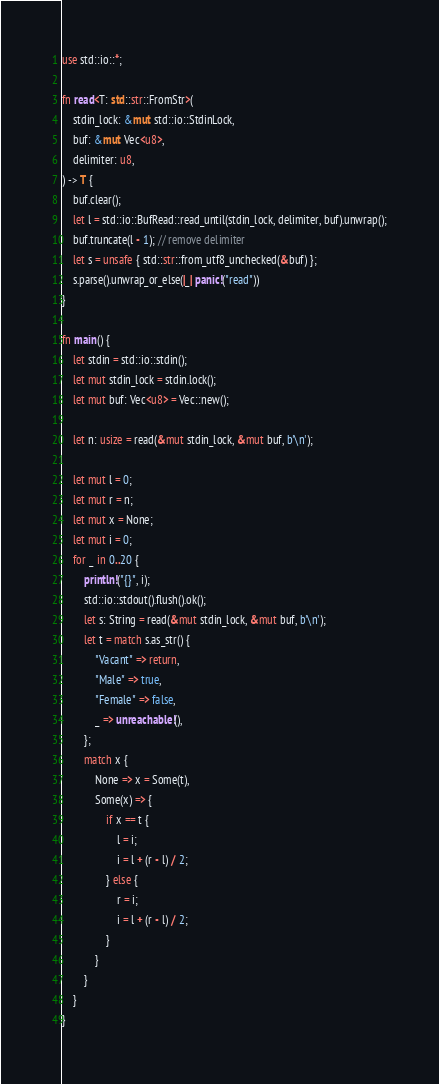Convert code to text. <code><loc_0><loc_0><loc_500><loc_500><_Rust_>use std::io::*;

fn read<T: std::str::FromStr>(
    stdin_lock: &mut std::io::StdinLock,
    buf: &mut Vec<u8>,
    delimiter: u8,
) -> T {
    buf.clear();
    let l = std::io::BufRead::read_until(stdin_lock, delimiter, buf).unwrap();
    buf.truncate(l - 1); // remove delimiter
    let s = unsafe { std::str::from_utf8_unchecked(&buf) };
    s.parse().unwrap_or_else(|_| panic!("read"))
}

fn main() {
    let stdin = std::io::stdin();
    let mut stdin_lock = stdin.lock();
    let mut buf: Vec<u8> = Vec::new();

    let n: usize = read(&mut stdin_lock, &mut buf, b'\n');

    let mut l = 0;
    let mut r = n;
    let mut x = None;
    let mut i = 0;
    for _ in 0..20 {
        println!("{}", i);
        std::io::stdout().flush().ok();
        let s: String = read(&mut stdin_lock, &mut buf, b'\n');
        let t = match s.as_str() {
            "Vacant" => return,
            "Male" => true,
            "Female" => false,
            _ => unreachable!(),
        };
        match x {
            None => x = Some(t),
            Some(x) => {
                if x == t {
                    l = i;
                    i = l + (r - l) / 2;
                } else {
                    r = i;
                    i = l + (r - l) / 2;
                }
            }
        }
    }
}
</code> 